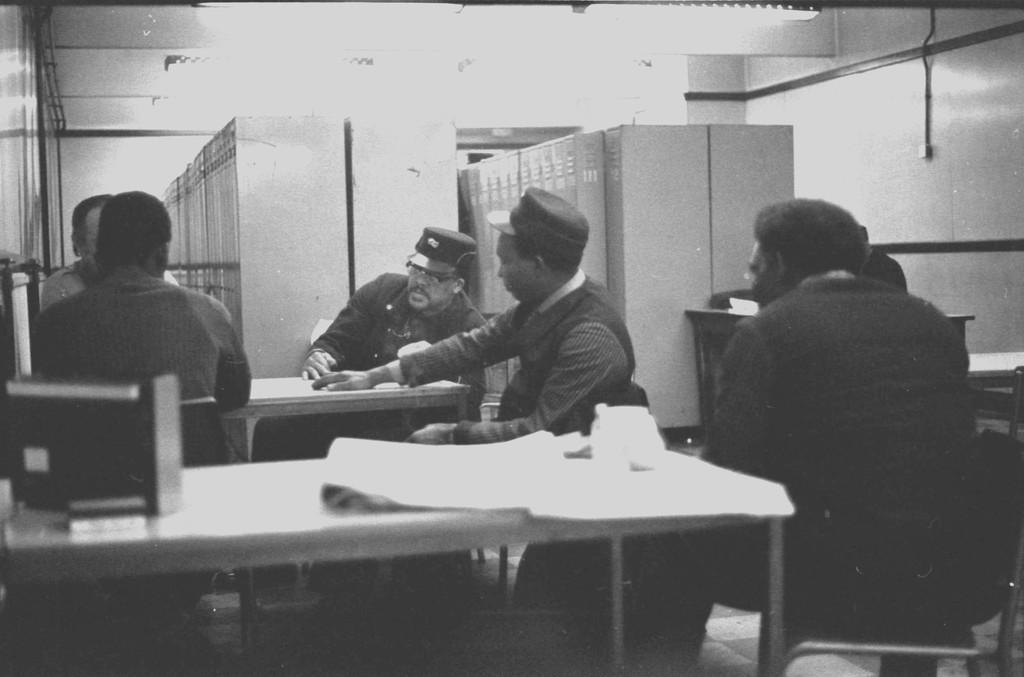What is the color scheme of the image? The image is black and white. What are the officers in the image doing? The officers are sitting around a table. What can be seen in the background of the image? There are lockers in the background of the image. Can you tell me the name of the cat sitting on the table in the image? There is no cat present in the image. What is the relation between the officers in the image? The provided facts do not give any information about the relationship between the officers. 